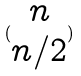Convert formula to latex. <formula><loc_0><loc_0><loc_500><loc_500>( \begin{matrix} n \\ n / 2 \end{matrix} )</formula> 